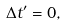Convert formula to latex. <formula><loc_0><loc_0><loc_500><loc_500>\Delta t ^ { \prime } = 0 ,</formula> 